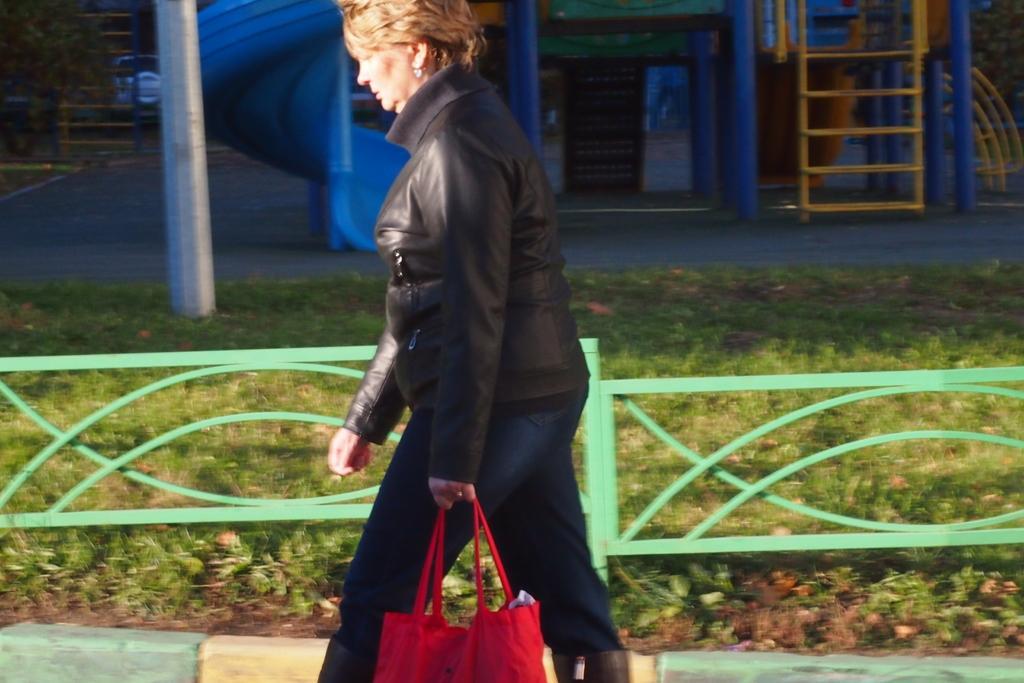How would you summarize this image in a sentence or two? As we can see in the image there is a grass, house, women wearing black color dress and holding red color handbag. 